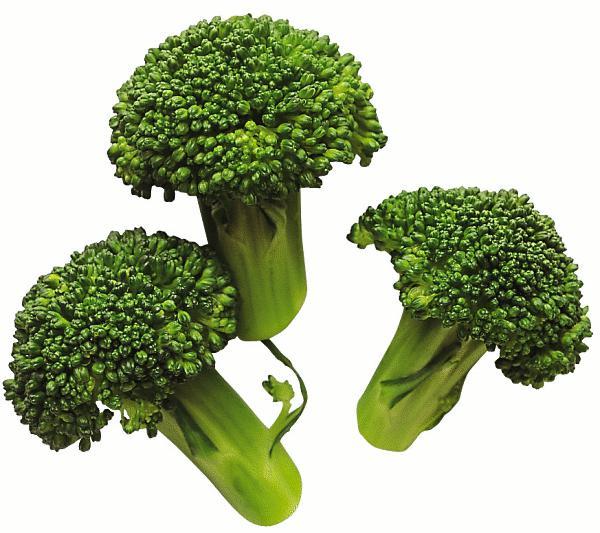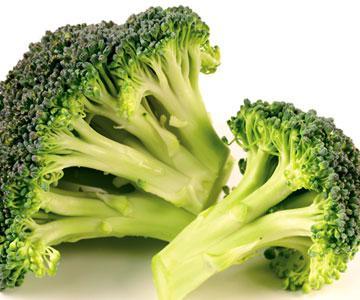The first image is the image on the left, the second image is the image on the right. Given the left and right images, does the statement "A total of five cut broccoli florets are shown." hold true? Answer yes or no. Yes. 